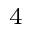Convert formula to latex. <formula><loc_0><loc_0><loc_500><loc_500>^ { 4 }</formula> 